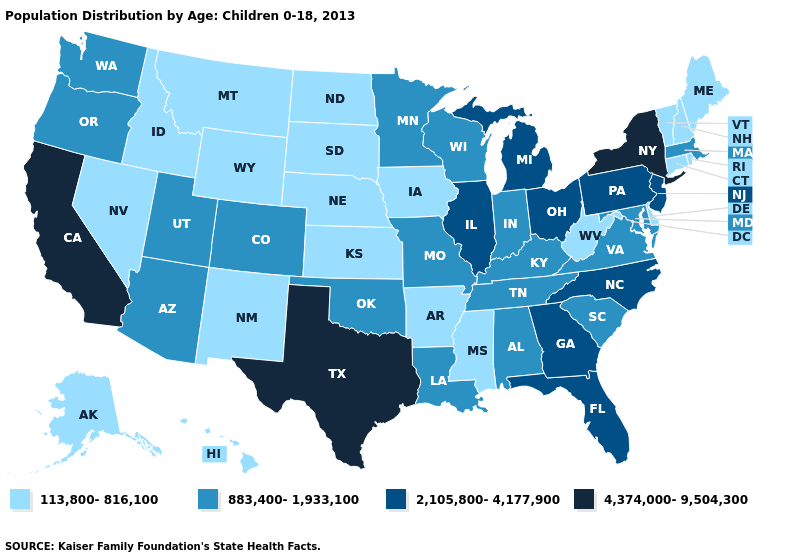What is the lowest value in the USA?
Concise answer only. 113,800-816,100. Name the states that have a value in the range 113,800-816,100?
Concise answer only. Alaska, Arkansas, Connecticut, Delaware, Hawaii, Idaho, Iowa, Kansas, Maine, Mississippi, Montana, Nebraska, Nevada, New Hampshire, New Mexico, North Dakota, Rhode Island, South Dakota, Vermont, West Virginia, Wyoming. Name the states that have a value in the range 2,105,800-4,177,900?
Quick response, please. Florida, Georgia, Illinois, Michigan, New Jersey, North Carolina, Ohio, Pennsylvania. Does Minnesota have the highest value in the USA?
Give a very brief answer. No. What is the highest value in the Northeast ?
Short answer required. 4,374,000-9,504,300. Among the states that border New Mexico , which have the highest value?
Be succinct. Texas. Among the states that border Oklahoma , does Texas have the lowest value?
Quick response, please. No. What is the value of Oregon?
Be succinct. 883,400-1,933,100. Among the states that border New Jersey , which have the highest value?
Be succinct. New York. Does Utah have the lowest value in the USA?
Short answer required. No. Among the states that border Oklahoma , which have the highest value?
Be succinct. Texas. Does Wisconsin have the lowest value in the USA?
Keep it brief. No. What is the value of Maryland?
Concise answer only. 883,400-1,933,100. Does the first symbol in the legend represent the smallest category?
Keep it brief. Yes. What is the highest value in the Northeast ?
Answer briefly. 4,374,000-9,504,300. 